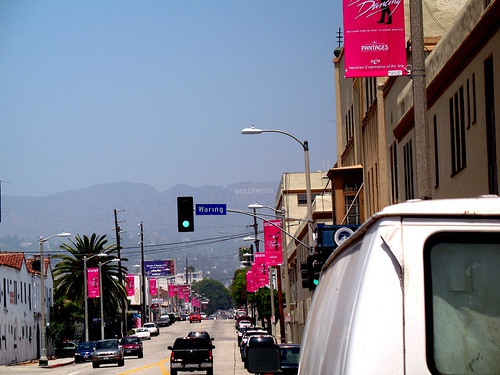Describe the objects in this image and their specific colors. I can see car in gray, white, darkgray, and black tones, truck in gray, black, darkgray, and maroon tones, car in gray, black, lightgray, and maroon tones, traffic light in gray, black, and darkgray tones, and truck in gray, black, darkgray, and navy tones in this image. 